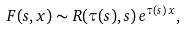<formula> <loc_0><loc_0><loc_500><loc_500>F ( s , x ) \sim R ( \tau ( s ) , s ) \, e ^ { \tau ( s ) \, x } ,</formula> 